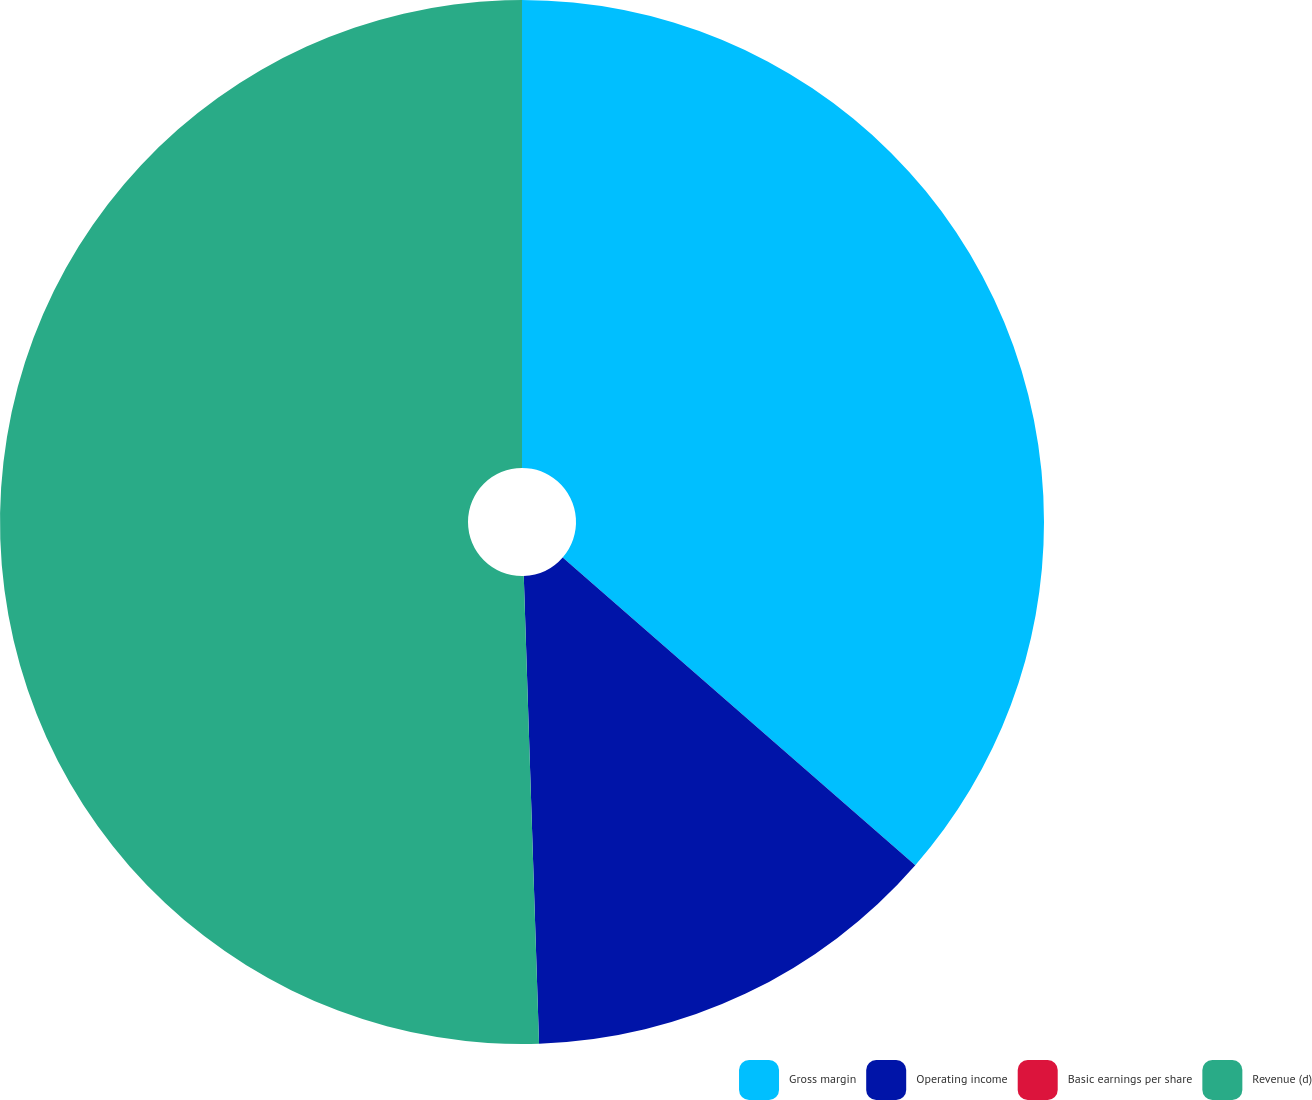Convert chart to OTSL. <chart><loc_0><loc_0><loc_500><loc_500><pie_chart><fcel>Gross margin<fcel>Operating income<fcel>Basic earnings per share<fcel>Revenue (d)<nl><fcel>36.42%<fcel>13.06%<fcel>0.0%<fcel>50.52%<nl></chart> 